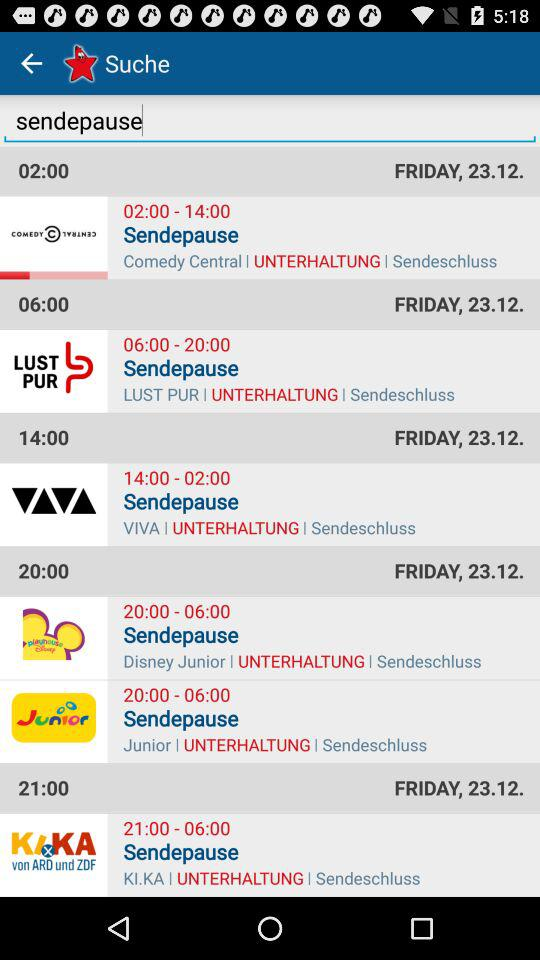What is the time for "Comedy Central"? The time is 02:00. 